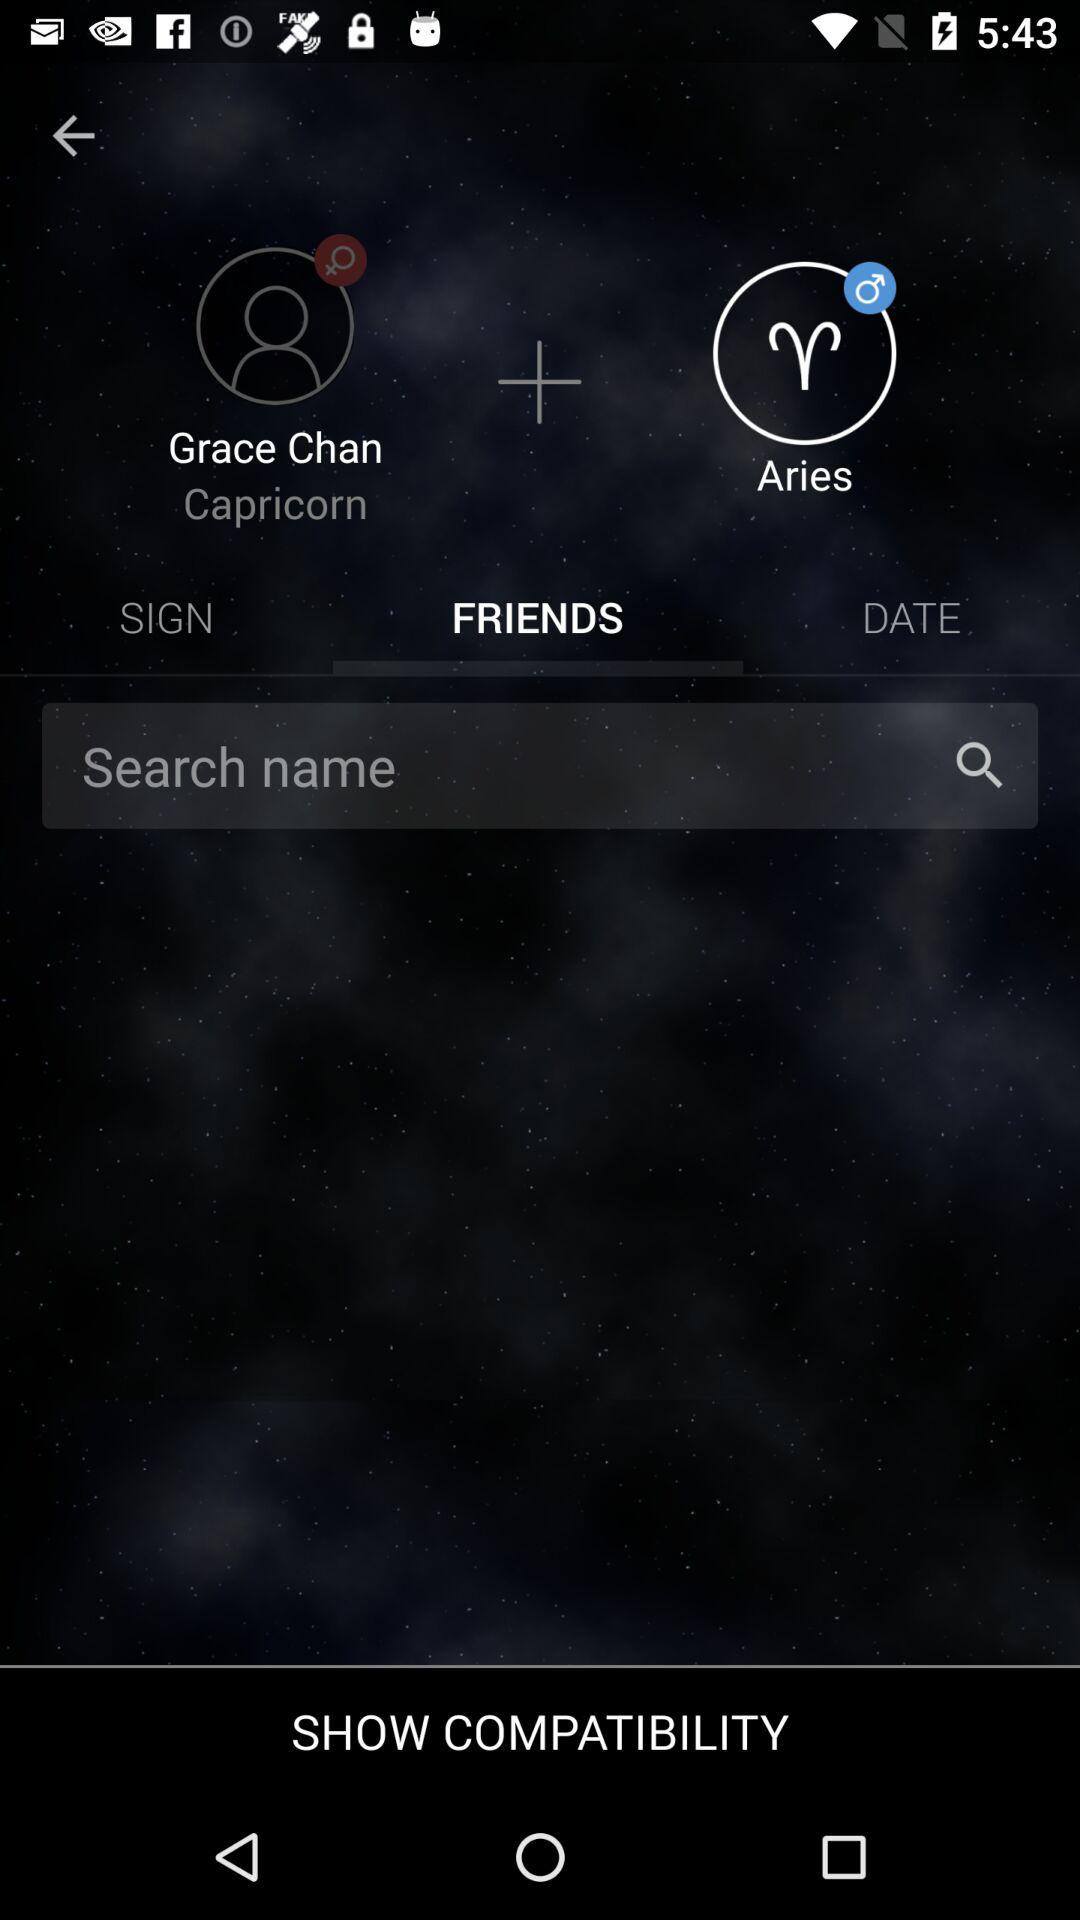Define the gender of aries?
When the provided information is insufficient, respond with <no answer>. <no answer> 